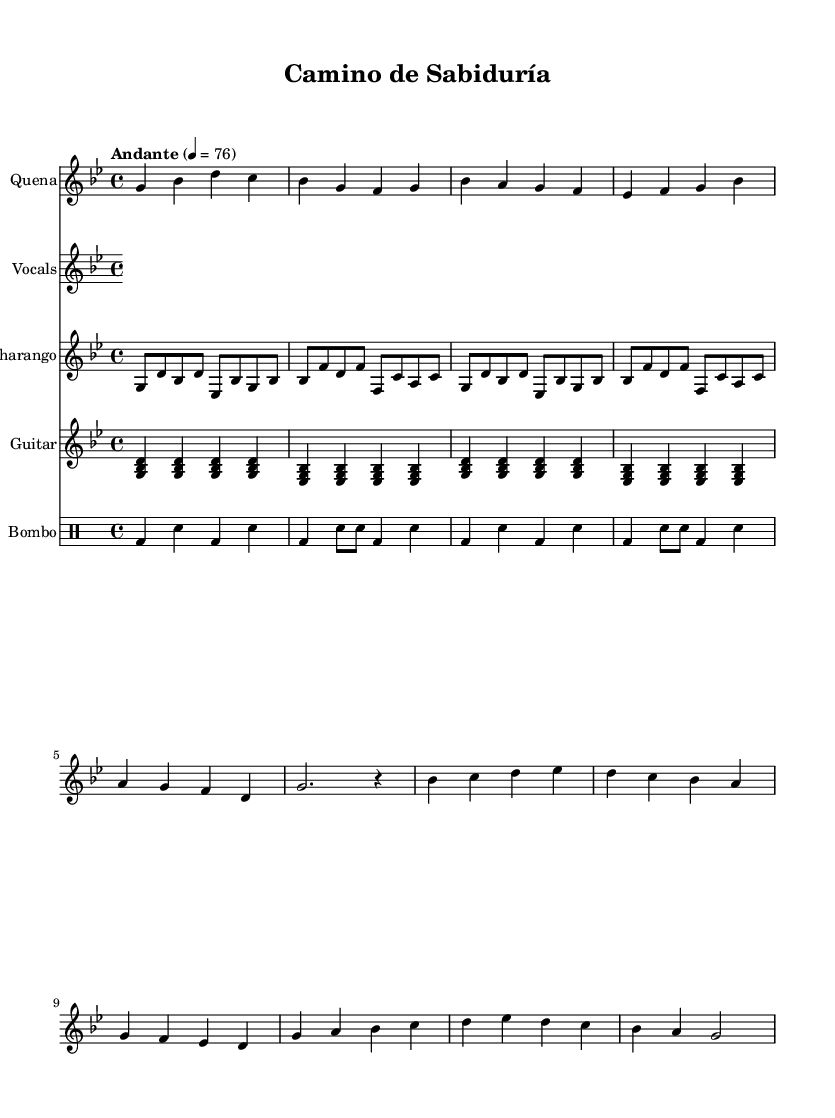What is the key signature of this music? The key signature is indicated at the beginning of the score and shows two flats, which is characteristic of G minor.
Answer: G minor What is the time signature of the piece? The time signature is shown at the beginning and is expressed as 4/4, meaning there are four beats in each measure.
Answer: 4/4 What tempo is indicated for this music? The tempo marking is found at the beginning and states "Andante" with a metronome marking of 76, indicating a moderately slow pace.
Answer: Andante 76 How many measures does the vocal line contain? By counting the total number of measures indicated in the vocal staff, there are 10 measures.
Answer: 10 What is the primary theme expressed in the lyrics? The lyrics depict a journey of lifelong learning and personal growth, as seen in phrases about searching for identity and lessons of life.
Answer: Journey of lifelong learning What instruments are included in the score? The score specifies five different staves: Quena, Vocals, Charango, Guitar, and Bombo, showing the variety of instruments used in this composition.
Answer: Quena, Vocals, Charango, Guitar, Bombo What is the main rhythmic pattern used in the Bombo part? The Bombo part features a repeated rhythm consisting of a bass drum and snare placement, organized into a 4-beat measure pattern.
Answer: Bass and snare pattern 